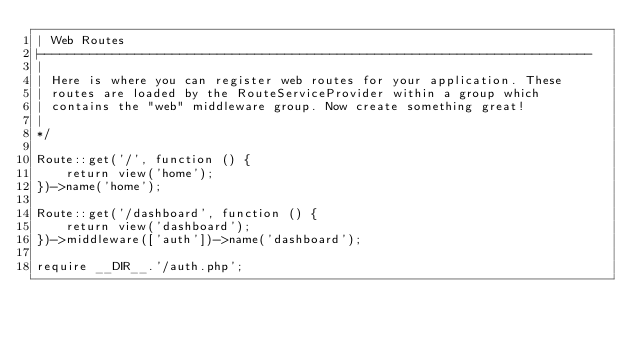<code> <loc_0><loc_0><loc_500><loc_500><_PHP_>| Web Routes
|--------------------------------------------------------------------------
|
| Here is where you can register web routes for your application. These
| routes are loaded by the RouteServiceProvider within a group which
| contains the "web" middleware group. Now create something great!
|
*/

Route::get('/', function () {
    return view('home');
})->name('home');

Route::get('/dashboard', function () {
    return view('dashboard');
})->middleware(['auth'])->name('dashboard');

require __DIR__.'/auth.php';
</code> 